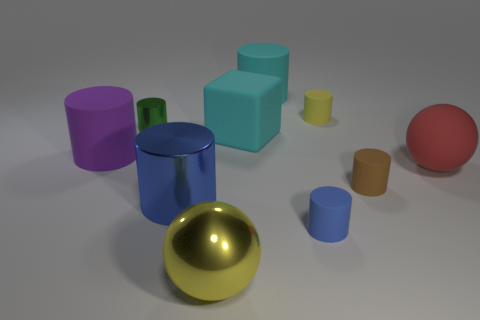Subtract all large rubber cylinders. How many cylinders are left? 5 Subtract all green cylinders. How many cylinders are left? 6 Subtract 0 gray balls. How many objects are left? 10 Subtract all blocks. How many objects are left? 9 Subtract 1 spheres. How many spheres are left? 1 Subtract all yellow blocks. Subtract all green cylinders. How many blocks are left? 1 Subtract all gray cylinders. How many red spheres are left? 1 Subtract all big blue cylinders. Subtract all big matte balls. How many objects are left? 8 Add 6 big red matte spheres. How many big red matte spheres are left? 7 Add 3 big matte objects. How many big matte objects exist? 7 